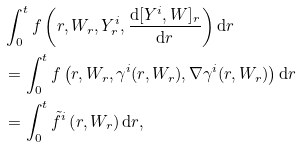Convert formula to latex. <formula><loc_0><loc_0><loc_500><loc_500>& \int _ { 0 } ^ { t } f \left ( r , W _ { r } , Y ^ { i } _ { r } , \frac { \mathrm d [ Y ^ { i } , W ] _ { r } } { \mathrm d r } \right ) \mathrm d r \\ & = \int _ { 0 } ^ { t } f \left ( r , W _ { r } , \gamma ^ { i } ( r , W _ { r } ) , \nabla \gamma ^ { i } ( r , W _ { r } ) \right ) \mathrm d r \\ & = \int _ { 0 } ^ { t } \tilde { f } ^ { i } \left ( r , W _ { r } \right ) \mathrm d r ,</formula> 